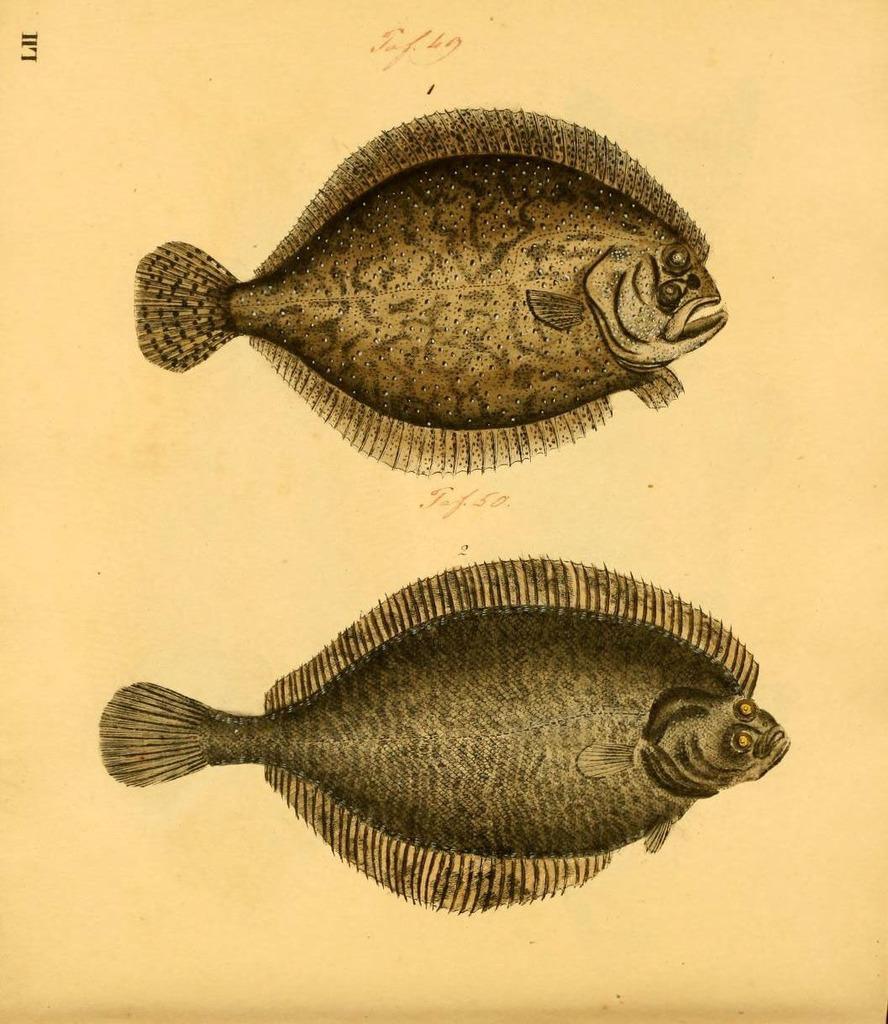Please provide a concise description of this image. In this image we can see drawings of fishes. 